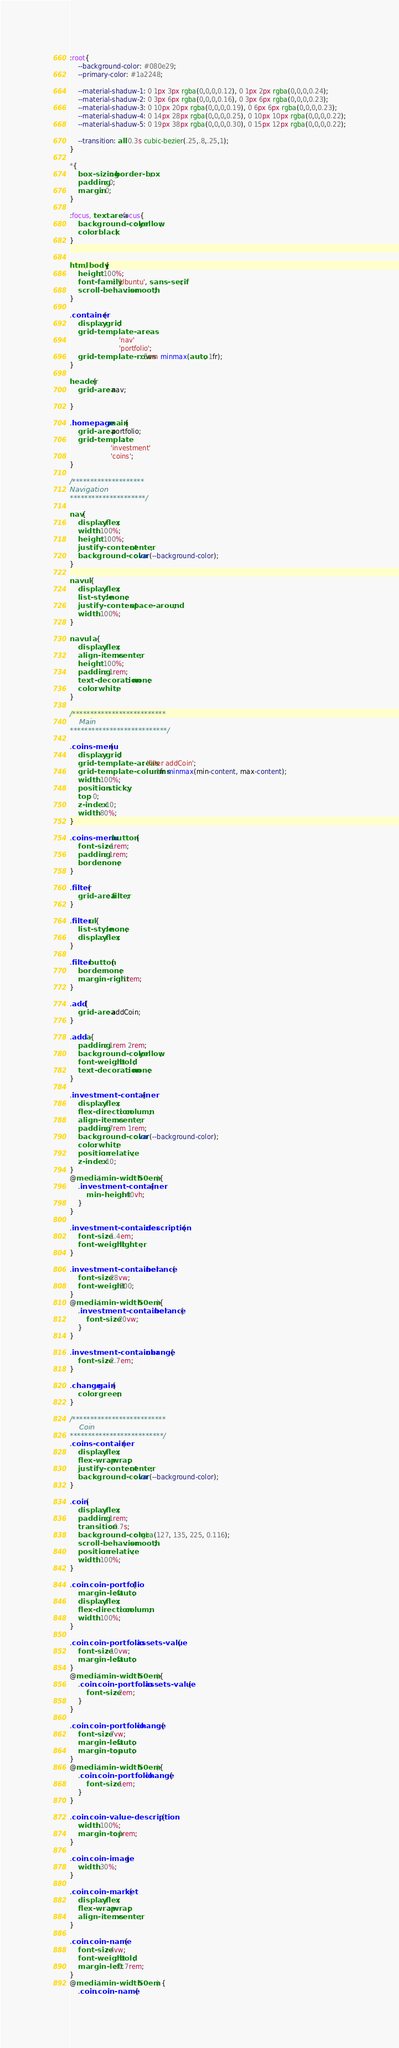<code> <loc_0><loc_0><loc_500><loc_500><_CSS_>:root{
    --background-color: #080e29;
    --primary-color: #1a2248;

    --material-shaduw-1: 0 1px 3px rgba(0,0,0,0.12), 0 1px 2px rgba(0,0,0,0.24);
    --material-shaduw-2: 0 3px 6px rgba(0,0,0,0.16), 0 3px 6px rgba(0,0,0,0.23);
    --material-shaduw-3: 0 10px 20px rgba(0,0,0,0.19), 0 6px 6px rgba(0,0,0,0.23);
    --material-shaduw-4: 0 14px 28px rgba(0,0,0,0.25), 0 10px 10px rgba(0,0,0,0.22);
    --material-shaduw-5: 0 19px 38px rgba(0,0,0,0.30), 0 15px 12px rgba(0,0,0,0.22);

    --transition: all 0.3s cubic-bezier(.25,.8,.25,1);
}

*{
    box-sizing: border-box;
    padding: 0;
    margin: 0;
}

:focus, textarea:focus{
    background-color: yellow;
    color: black;
}


html, body{
    height: 100%;
    font-family: 'Ubuntu', sans-serif;
    scroll-behavior: smooth;
}

.container{
    display: grid;
    grid-template-areas: 
                        'nav'
                        'portfolio';
    grid-template-rows: 5em minmax(auto, 1fr);
}

header{
    grid-area: nav;

}

.homepage main{
    grid-area: portfolio;
    grid-template: 
                    'investment'
                    'coins';
}

/********************
Navigation
*********************/

nav{
    display: flex;
    width: 100%;
    height: 100%;
    justify-content: center;
    background-color: var(--background-color);
}

nav ul{
    display: flex;
    list-style: none;
    justify-content: space-around;
    width: 100%;
}

nav ul a{
    display: flex;
    align-items: center;
    height: 100%;
    padding: 1rem;
    text-decoration: none;
    color: white;
}

/**************************
    Main
***************************/

.coins-menu{
    display: grid;
    grid-template-areas: 'filter addCoin';
    grid-template-columns: 1fr minmax(min-content, max-content);
    width: 100%;
    position: sticky;
    top: 0;
    z-index: 10;
    width: 80%;
}

.coins-menu button {
    font-size: 1rem;
    padding: 1rem;
    border:none;
}

.filter{
    grid-area: filter;
}

.filter ul{
    list-style: none;
    display: flex;
}

.filter button{
    border: none;
    margin-right: 1rem;
}

.add{
    grid-area: addCoin;
}

.add a{
    padding: 1rem 2rem;
    background-color: yellow;
    font-weight: bold;
    text-decoration: none;
}

.investment-container{
    display: flex;
    flex-direction: column;
    align-items: center;
    padding: 7rem 1rem;
    background-color: var(--background-color);
    color: white;
    position: relative;
    z-index: 10;
}
@media (min-width: 50em){
    .investment-container{
        min-height: 60vh;
    }
}

.investment-container .description{
    font-size: 1.4em;
    font-weight: lighter;
}

.investment-container .belance{
    font-size: 28vw;
    font-weight: 800;
}
@media (min-width: 50em){
    .investment-container .belance{
        font-size: 20vw;
    }
}

.investment-container .change{
    font-size: 2.7em;
}

.change.gain{
    color: green;
}

/**************************
    Coin
**************************/
.coins-container{
    display: flex;
    flex-wrap: wrap;
    justify-content: center;
    background-color: var(--background-color);
}

.coin{
    display: flex;
    padding: 1rem;
    transition: 0.7s;
    background-color: rgba(127, 135, 225, 0.116);
    scroll-behavior: smooth;
    position: relative;
    width: 100%;
}

.coin .coin-portfolio{
    margin-left: auto;
    display: flex;
    flex-direction: column;
    width: 100%;
}

.coin .coin-portfolio .assets-value{
    font-size: 10vw;
    margin-left: auto;
}
@media (min-width: 50em){
    .coin .coin-portfolio .assets-value {
        font-size: 2em;
    }
}

.coin .coin-portfolio .change{
    font-size: 7vw;
    margin-left: auto;
    margin-top: auto;
}
@media (min-width: 50em){
    .coin .coin-portfolio .change{
        font-size: 1em;
    }
}

.coin .coin-value-description{
    width: 100%;
    margin-top: 1rem;
}

.coin .coin-image{
    width: 30%;
}

.coin .coin-market{
    display: flex;
    flex-wrap: wrap;
    align-items: center;
}

.coin .coin-name{
    font-size: 4vw;
    font-weight: bold;
    margin-left: 0.7rem;
}
@media (min-width: 50em) {
    .coin .coin-name {</code> 